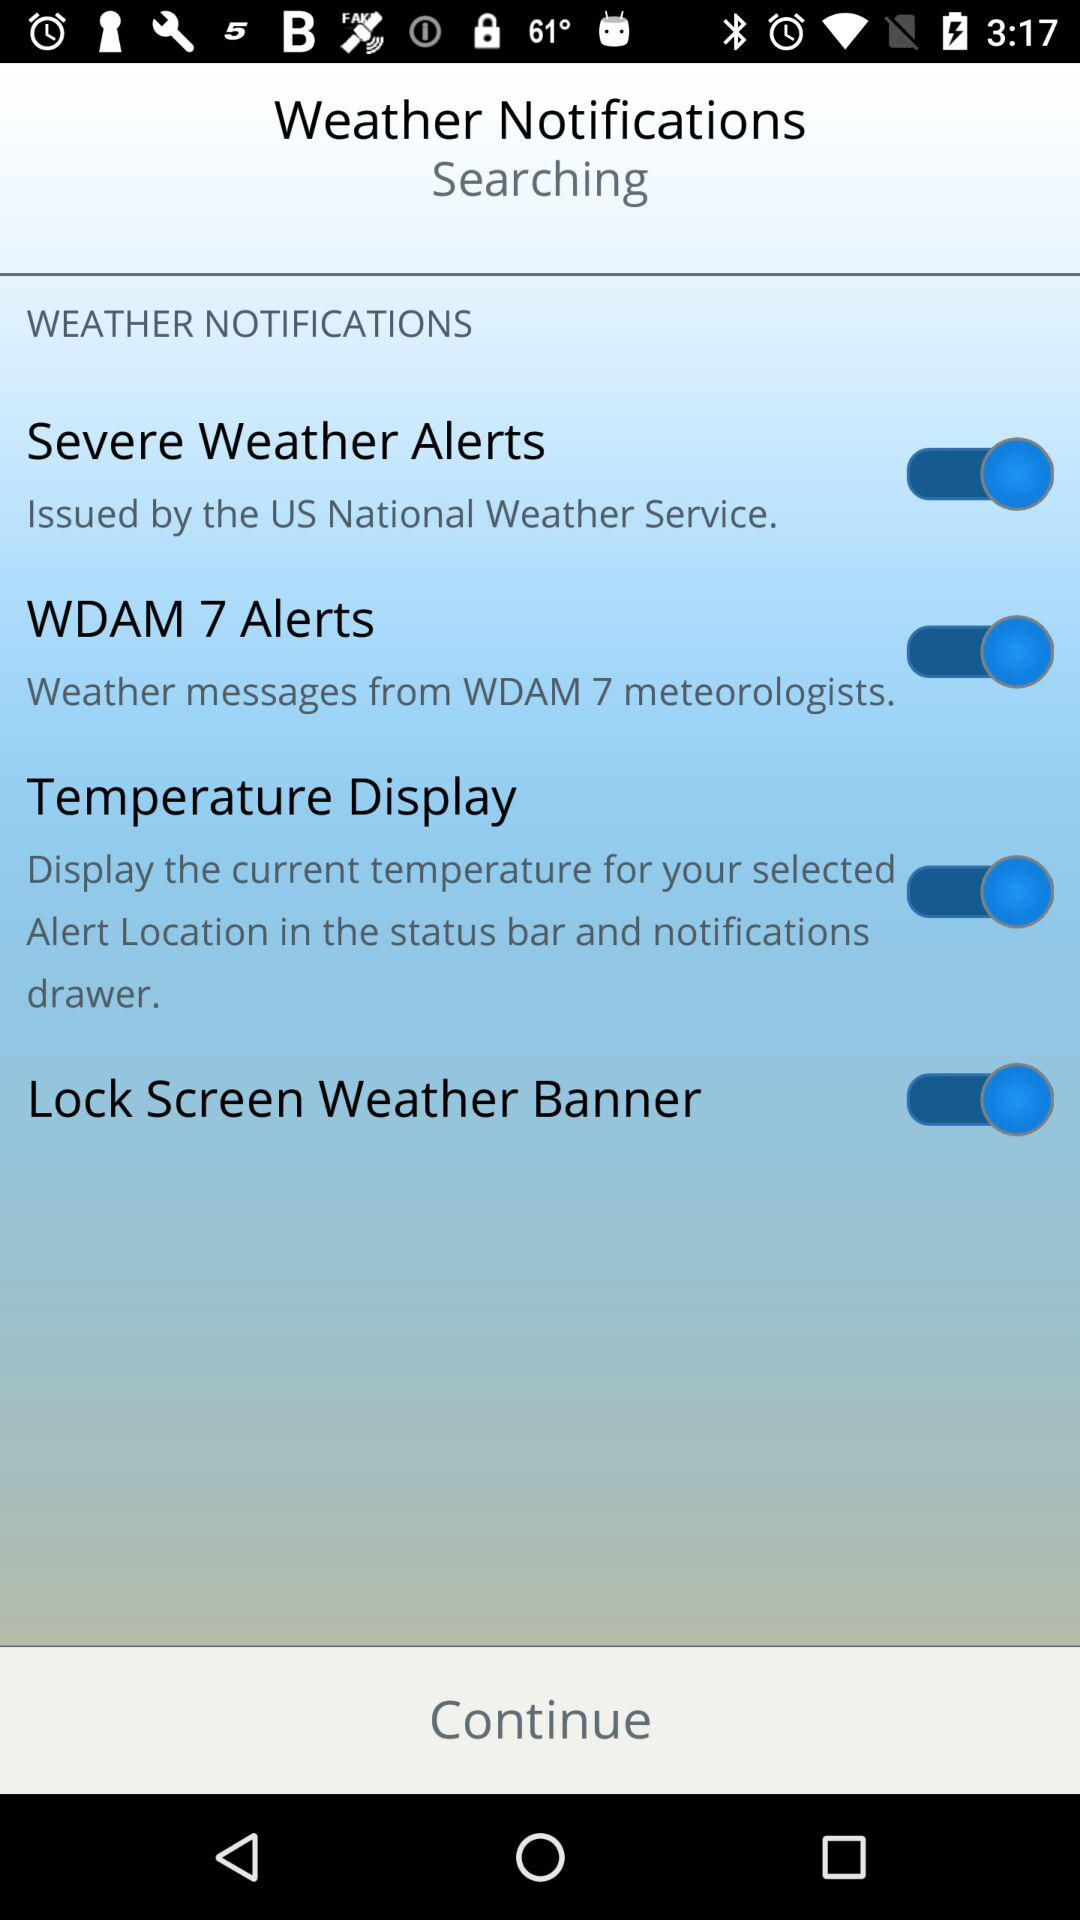By what agency were severe weather alerts issued? Severe weather alerts were issued by the "US National Weather Service". 